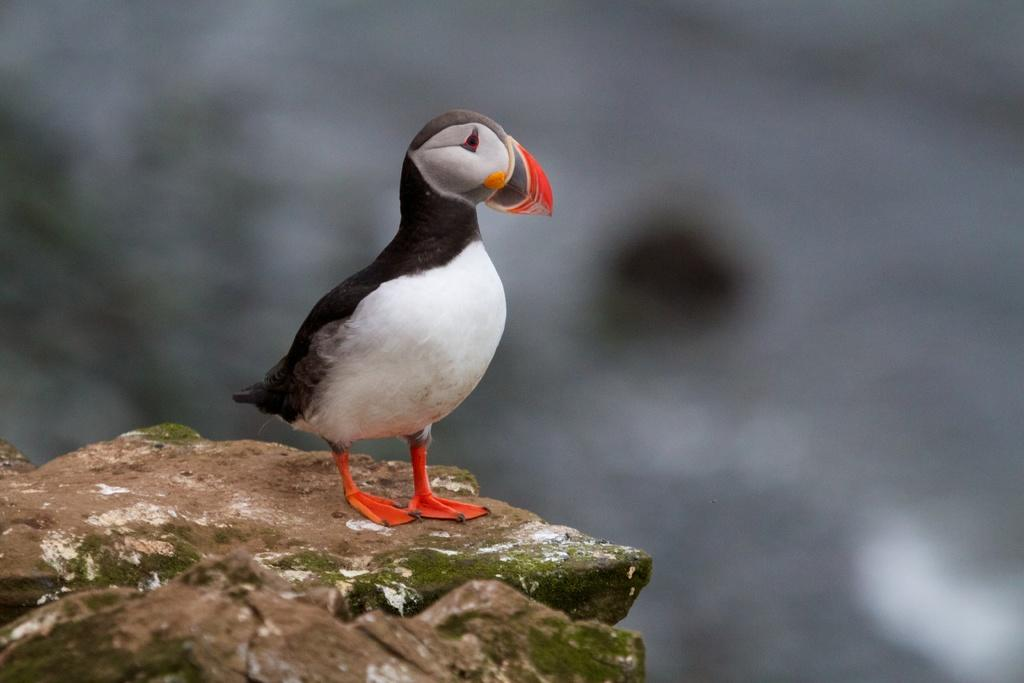What type of animal can be seen on the ground in the image? There is a bird on the ground in the image. Can you describe the background of the image? The background of the image is blurry. What type of beef is being prepared in the image? There is no beef present in the image; it features a bird on the ground and a blurry background. 